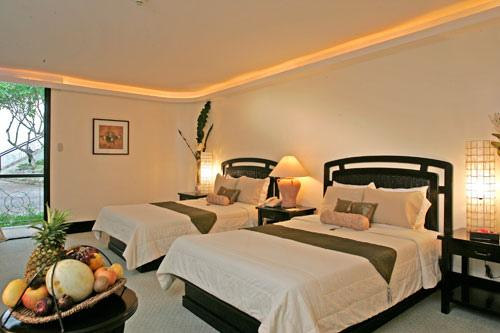Describe the assortment of fruit in the hotel room scene. A wicker basket holds a variety of fruits, including an uncut pineapple, a honeydew melon, and possibly an uncut cantaloupe. Discuss the role of natural elements in the image. A tall leafy plant and a spindly tree outside the window bring life and greenery into the hotel bedroom scene. Mention the primary furniture items in the image. Two large beds, a nightstand, a table with a basket of fruit, and a wooden nightstand. Provide a brief overview of the image's primary elements. Two neatly made beds, lamps on either side, a plant in the corner, and a basket of fruit on a table in a hotel room. Elaborate on the decorative elements featured in the image. Framed paintings adorn the walls, a decorative lattice lamp illuminates the right side, and a basket of fruit adds a touch of freshness. Narrate the image's ambiance through its furnishings and accessories. A cozy hotel bedroom with two inviting beds, adorned with cushions and drapes, warm lighting from decorative lamps, and a welcoming fruit basket. Characterize the textiles and materials visible in the image. White bedcovers, beige painted walls, grey berber carpet, and black wooden accents create a coordinated and elegant look. Explain how the lighting elements contribute to the image's atmosphere. Lamps on both sides of the beds and at the center create a warm and inviting ambiance in the hotel room. Describe the color scheme and style of the room in the image. The room has beige painted walls and ceiling, grey berber carpet, white bedcovers, and decorative lamps on both sides. Illustrate the scene set by the centerpiece of the image. A hotel room featuring two comfortable beds with white linens, lamps casting a warm glow, and a welcoming fruit arrangement on a nearby table. 